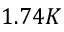<formula> <loc_0><loc_0><loc_500><loc_500>1 . 7 4 K</formula> 